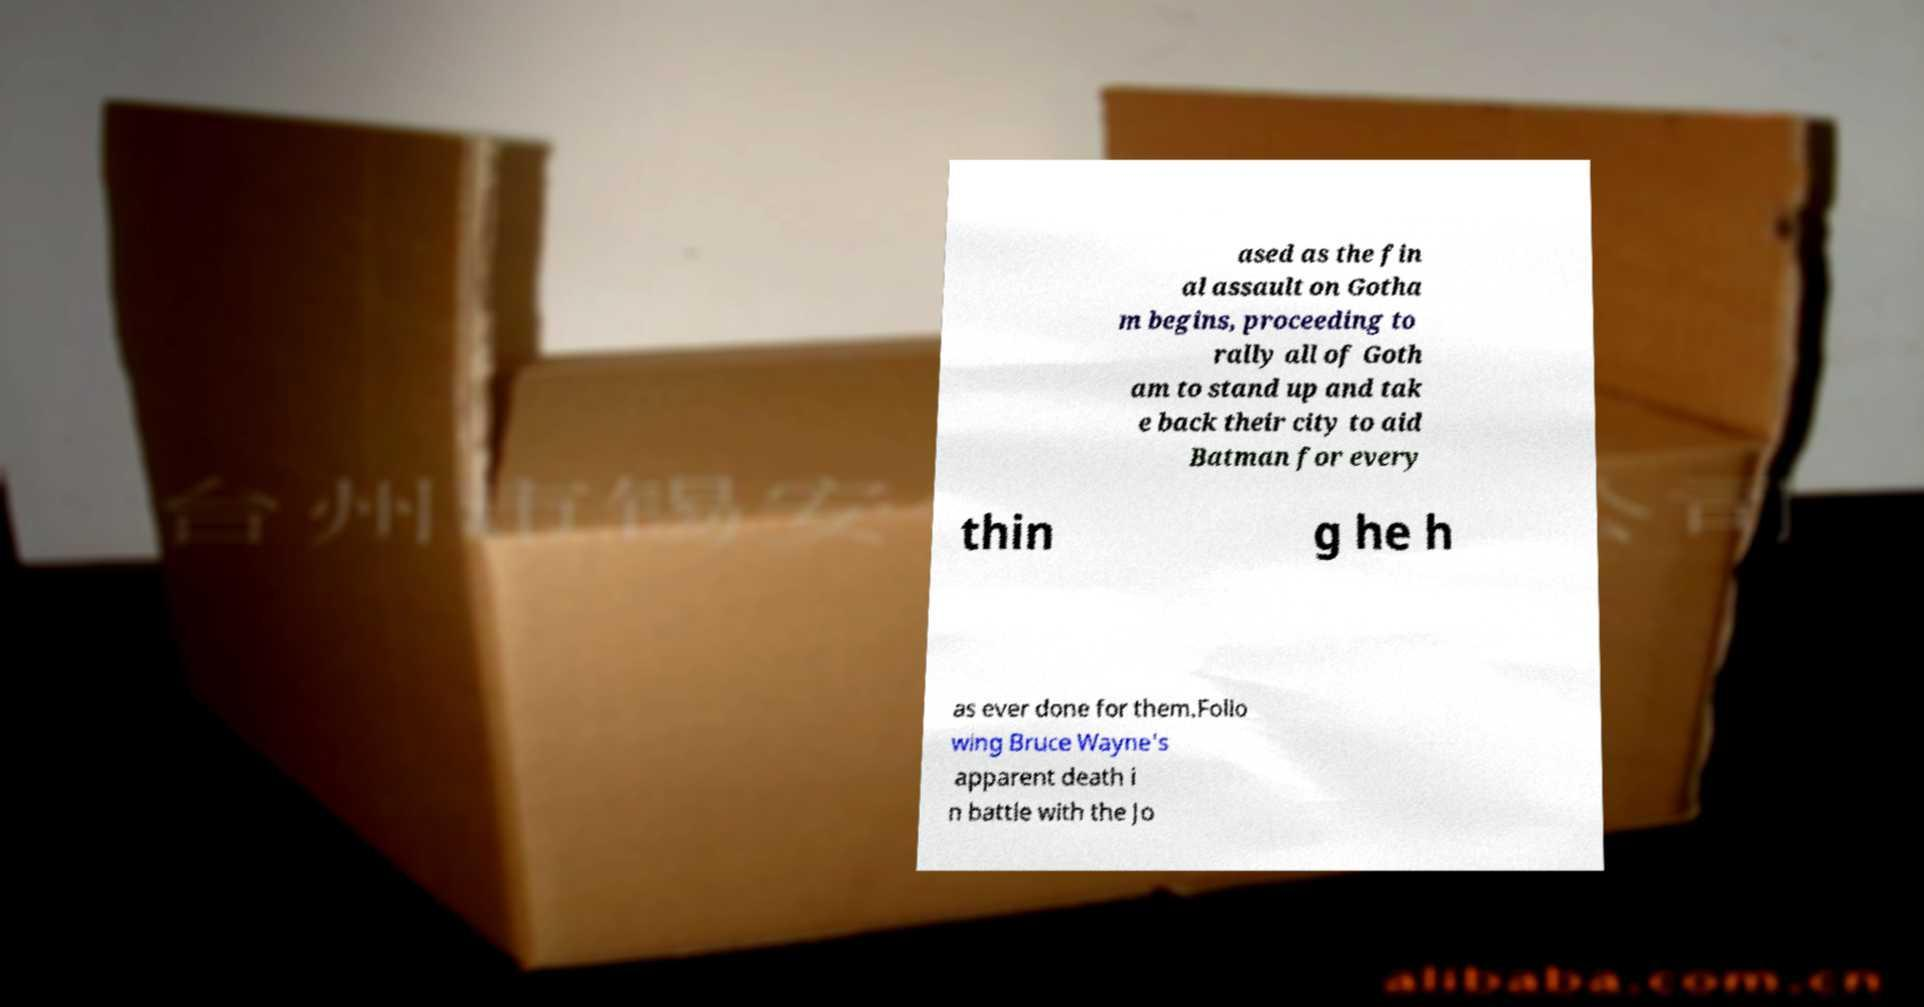I need the written content from this picture converted into text. Can you do that? ased as the fin al assault on Gotha m begins, proceeding to rally all of Goth am to stand up and tak e back their city to aid Batman for every thin g he h as ever done for them.Follo wing Bruce Wayne's apparent death i n battle with the Jo 